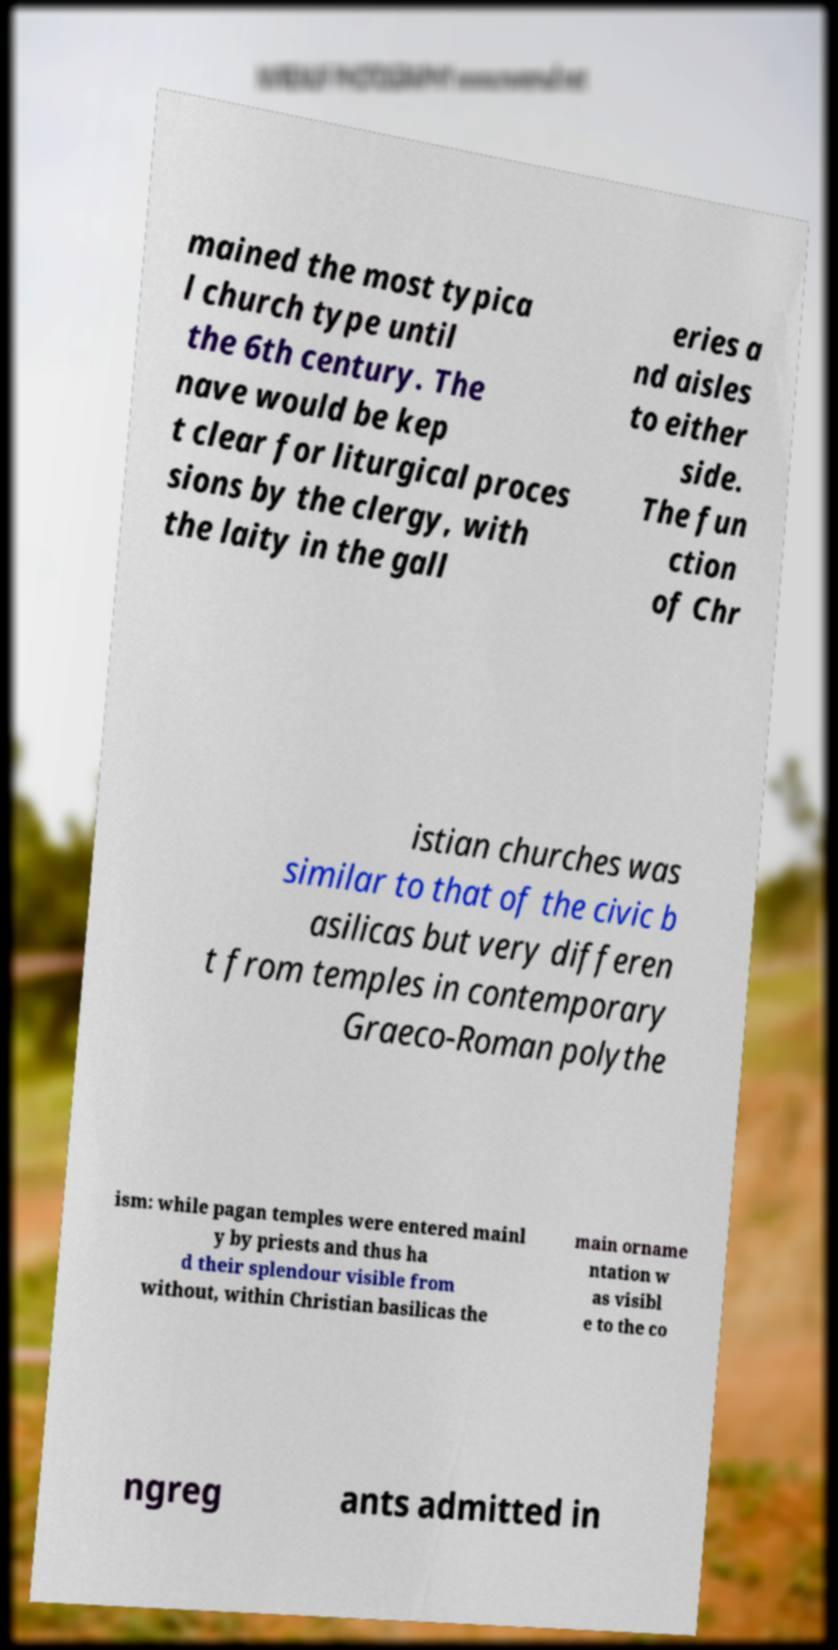Could you assist in decoding the text presented in this image and type it out clearly? mained the most typica l church type until the 6th century. The nave would be kep t clear for liturgical proces sions by the clergy, with the laity in the gall eries a nd aisles to either side. The fun ction of Chr istian churches was similar to that of the civic b asilicas but very differen t from temples in contemporary Graeco-Roman polythe ism: while pagan temples were entered mainl y by priests and thus ha d their splendour visible from without, within Christian basilicas the main orname ntation w as visibl e to the co ngreg ants admitted in 